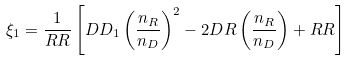<formula> <loc_0><loc_0><loc_500><loc_500>\xi _ { 1 } = \frac { 1 } { R R } \left [ D D _ { 1 } \left ( \frac { n _ { R } } { n _ { D } } \right ) ^ { 2 } - 2 D R \left ( \frac { n _ { R } } { n _ { D } } \right ) + R R \right ]</formula> 